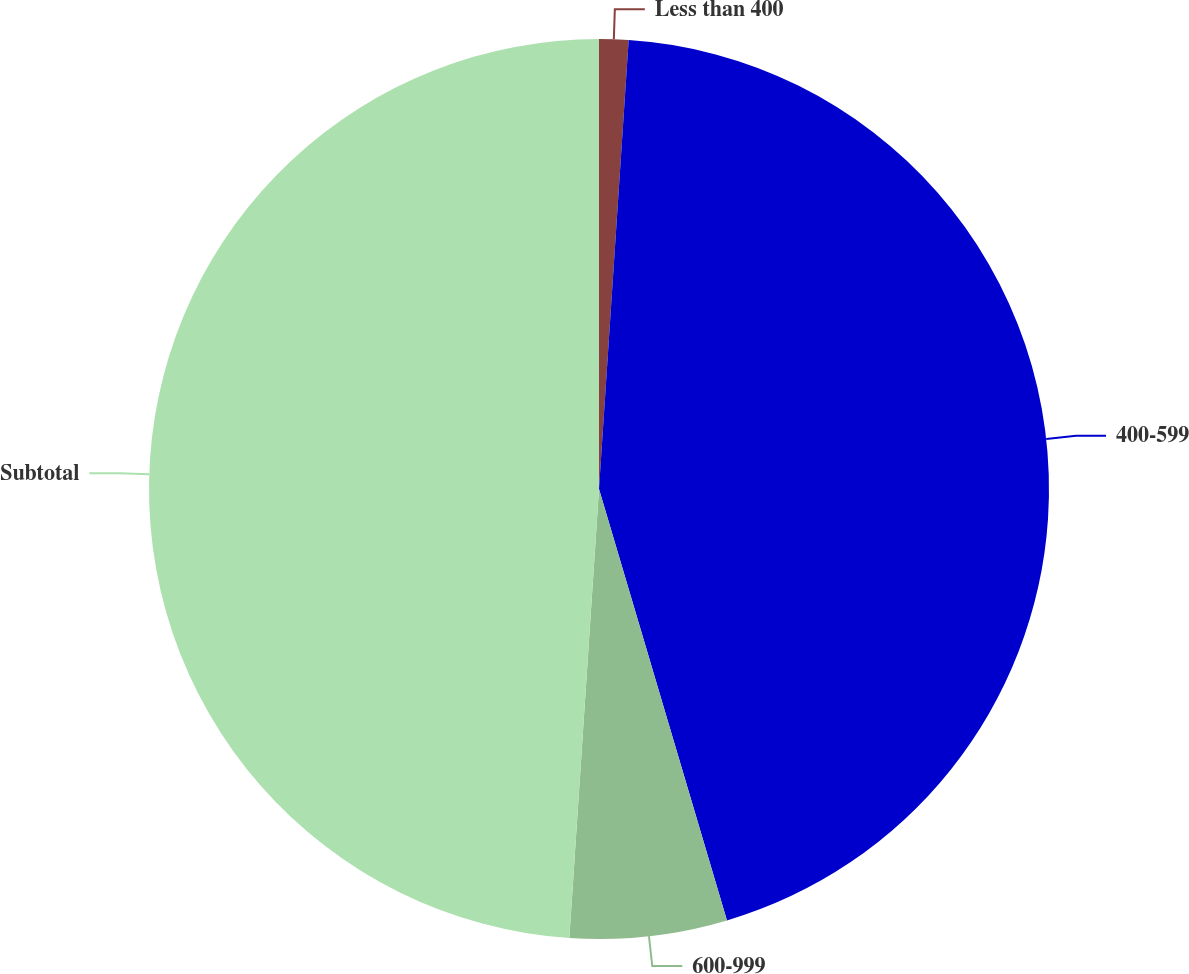Convert chart. <chart><loc_0><loc_0><loc_500><loc_500><pie_chart><fcel>Less than 400<fcel>400-599<fcel>600-999<fcel>Subtotal<nl><fcel>1.05%<fcel>44.36%<fcel>5.64%<fcel>48.95%<nl></chart> 